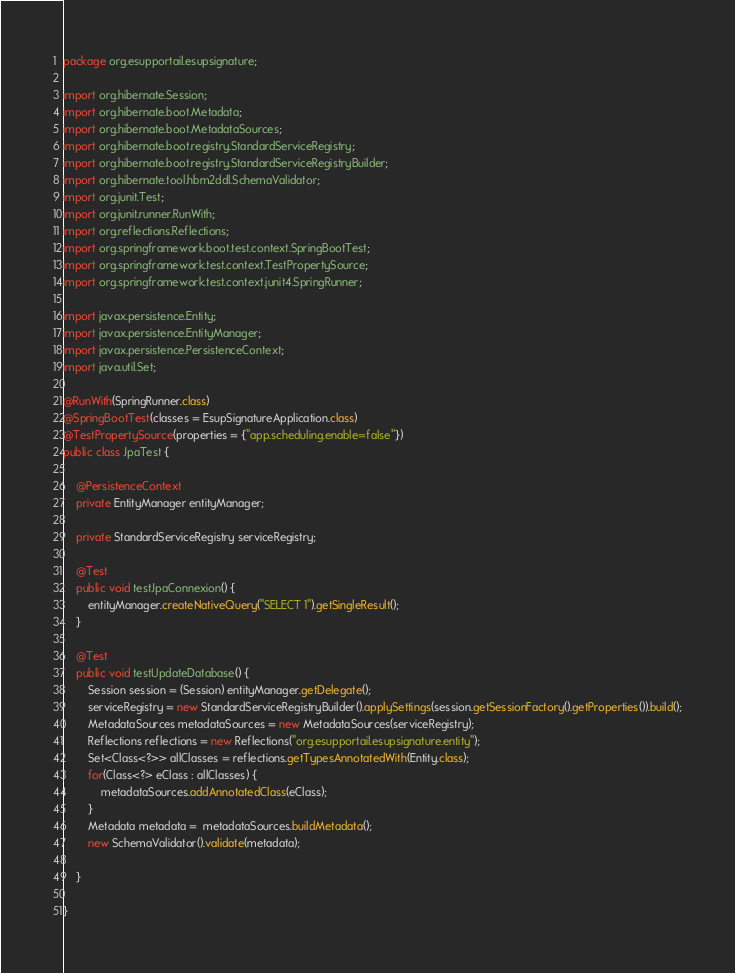Convert code to text. <code><loc_0><loc_0><loc_500><loc_500><_Java_>package org.esupportail.esupsignature;

import org.hibernate.Session;
import org.hibernate.boot.Metadata;
import org.hibernate.boot.MetadataSources;
import org.hibernate.boot.registry.StandardServiceRegistry;
import org.hibernate.boot.registry.StandardServiceRegistryBuilder;
import org.hibernate.tool.hbm2ddl.SchemaValidator;
import org.junit.Test;
import org.junit.runner.RunWith;
import org.reflections.Reflections;
import org.springframework.boot.test.context.SpringBootTest;
import org.springframework.test.context.TestPropertySource;
import org.springframework.test.context.junit4.SpringRunner;

import javax.persistence.Entity;
import javax.persistence.EntityManager;
import javax.persistence.PersistenceContext;
import java.util.Set;

@RunWith(SpringRunner.class)
@SpringBootTest(classes = EsupSignatureApplication.class)
@TestPropertySource(properties = {"app.scheduling.enable=false"})
public class JpaTest {

    @PersistenceContext
    private EntityManager entityManager;

    private StandardServiceRegistry serviceRegistry;

    @Test
    public void testJpaConnexion() {
        entityManager.createNativeQuery("SELECT 1").getSingleResult();
    }

    @Test
    public void testUpdateDatabase() {
        Session session = (Session) entityManager.getDelegate();
        serviceRegistry = new StandardServiceRegistryBuilder().applySettings(session.getSessionFactory().getProperties()).build();
        MetadataSources metadataSources = new MetadataSources(serviceRegistry);
        Reflections reflections = new Reflections("org.esupportail.esupsignature.entity");
        Set<Class<?>> allClasses = reflections.getTypesAnnotatedWith(Entity.class);
        for(Class<?> eClass : allClasses) {
            metadataSources.addAnnotatedClass(eClass);
        }
        Metadata metadata =  metadataSources.buildMetadata();
        new SchemaValidator().validate(metadata);

    }

}</code> 